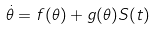Convert formula to latex. <formula><loc_0><loc_0><loc_500><loc_500>\dot { \theta } = f ( \theta ) + g ( \theta ) S ( t )</formula> 